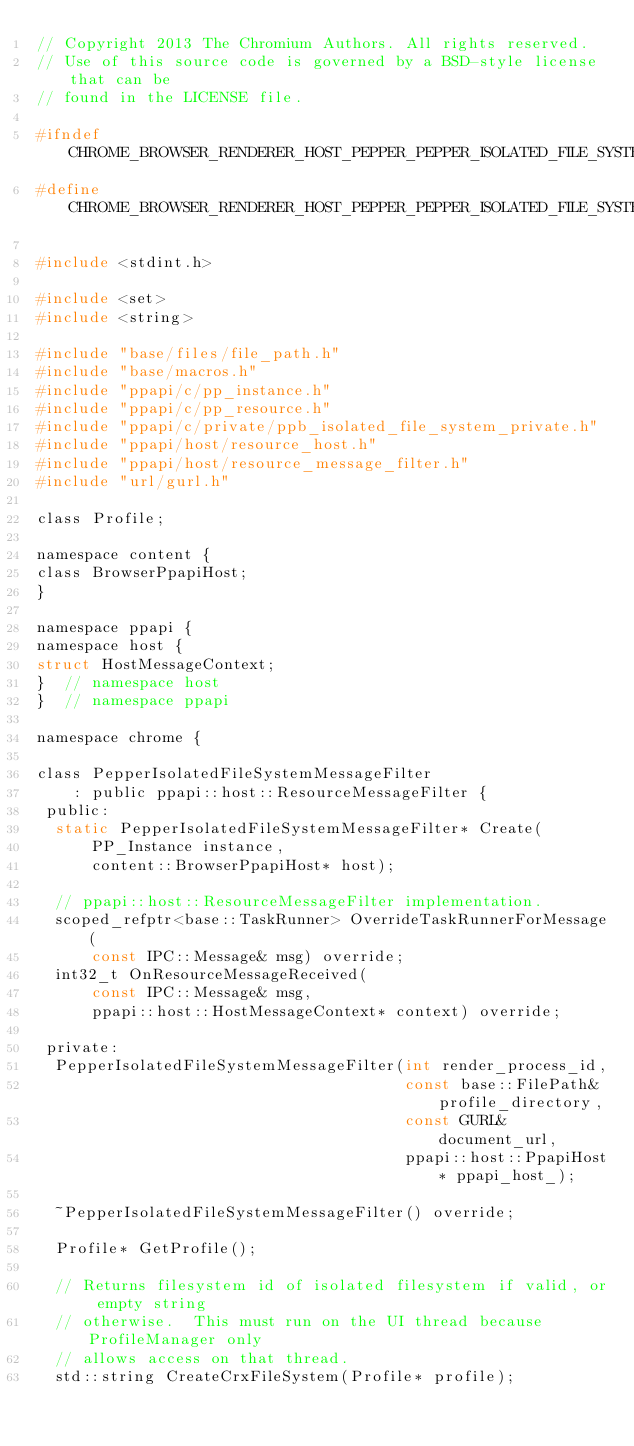Convert code to text. <code><loc_0><loc_0><loc_500><loc_500><_C_>// Copyright 2013 The Chromium Authors. All rights reserved.
// Use of this source code is governed by a BSD-style license that can be
// found in the LICENSE file.

#ifndef CHROME_BROWSER_RENDERER_HOST_PEPPER_PEPPER_ISOLATED_FILE_SYSTEM_MESSAGE_FILTER_H_
#define CHROME_BROWSER_RENDERER_HOST_PEPPER_PEPPER_ISOLATED_FILE_SYSTEM_MESSAGE_FILTER_H_

#include <stdint.h>

#include <set>
#include <string>

#include "base/files/file_path.h"
#include "base/macros.h"
#include "ppapi/c/pp_instance.h"
#include "ppapi/c/pp_resource.h"
#include "ppapi/c/private/ppb_isolated_file_system_private.h"
#include "ppapi/host/resource_host.h"
#include "ppapi/host/resource_message_filter.h"
#include "url/gurl.h"

class Profile;

namespace content {
class BrowserPpapiHost;
}

namespace ppapi {
namespace host {
struct HostMessageContext;
}  // namespace host
}  // namespace ppapi

namespace chrome {

class PepperIsolatedFileSystemMessageFilter
    : public ppapi::host::ResourceMessageFilter {
 public:
  static PepperIsolatedFileSystemMessageFilter* Create(
      PP_Instance instance,
      content::BrowserPpapiHost* host);

  // ppapi::host::ResourceMessageFilter implementation.
  scoped_refptr<base::TaskRunner> OverrideTaskRunnerForMessage(
      const IPC::Message& msg) override;
  int32_t OnResourceMessageReceived(
      const IPC::Message& msg,
      ppapi::host::HostMessageContext* context) override;

 private:
  PepperIsolatedFileSystemMessageFilter(int render_process_id,
                                        const base::FilePath& profile_directory,
                                        const GURL& document_url,
                                        ppapi::host::PpapiHost* ppapi_host_);

  ~PepperIsolatedFileSystemMessageFilter() override;

  Profile* GetProfile();

  // Returns filesystem id of isolated filesystem if valid, or empty string
  // otherwise.  This must run on the UI thread because ProfileManager only
  // allows access on that thread.
  std::string CreateCrxFileSystem(Profile* profile);
</code> 